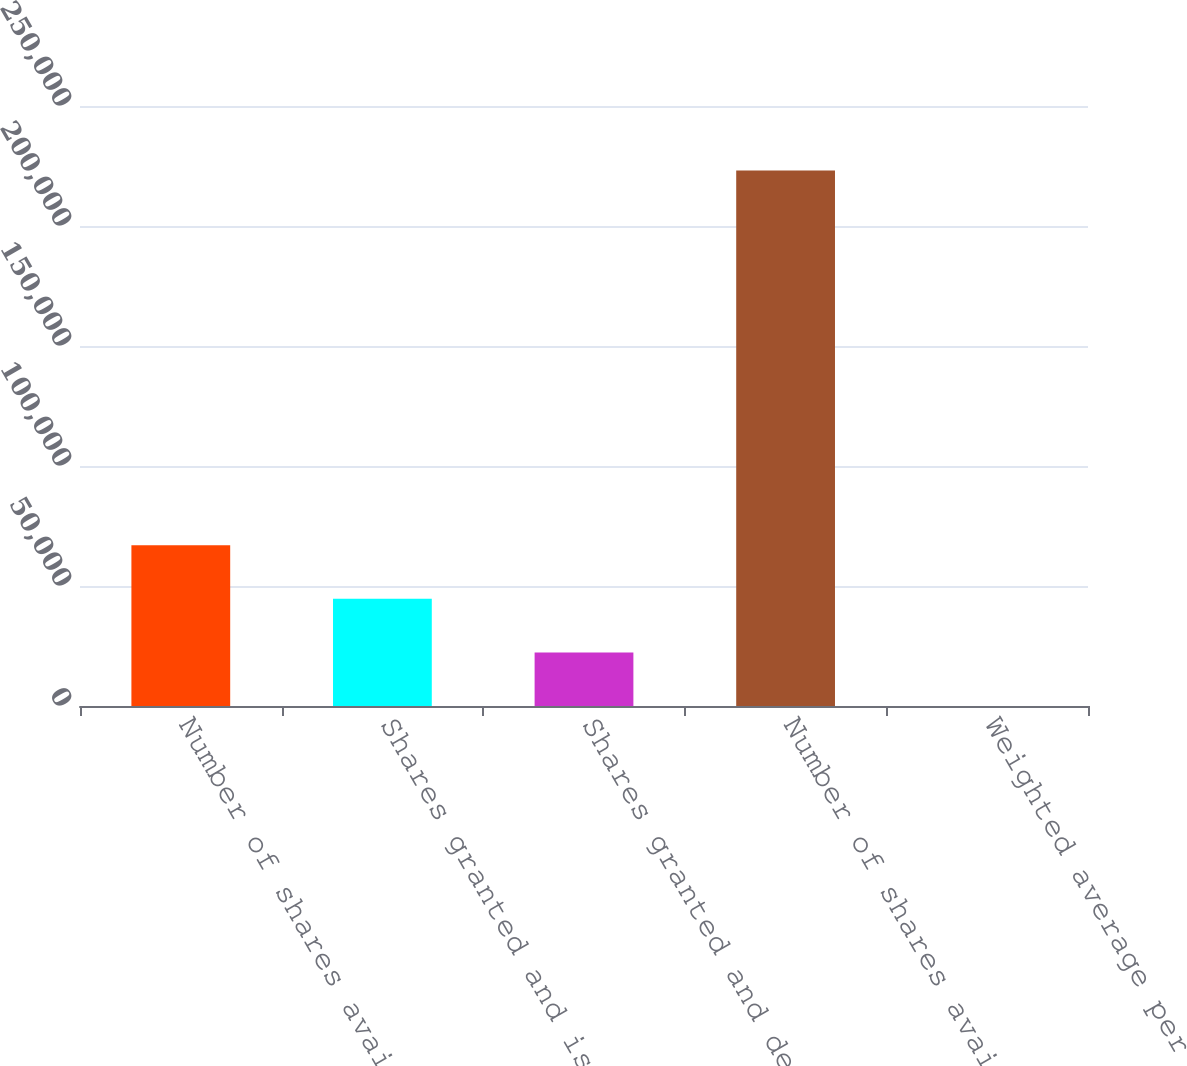<chart> <loc_0><loc_0><loc_500><loc_500><bar_chart><fcel>Number of shares available<fcel>Shares granted and issued<fcel>Shares granted and deferred<fcel>Number of shares available end<fcel>Weighted average per share<nl><fcel>66964.8<fcel>44651.8<fcel>22338.8<fcel>223156<fcel>25.77<nl></chart> 